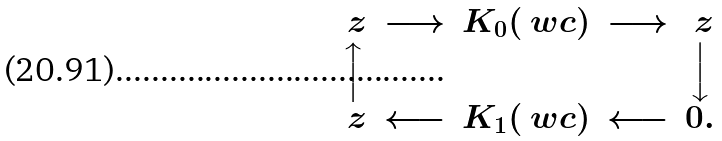Convert formula to latex. <formula><loc_0><loc_0><loc_500><loc_500>\begin{array} { c c c c c } \ z & \longrightarrow & K _ { 0 } ( \ w c ) & \longrightarrow & \ z \\ \Big \uparrow & & & & \Big \downarrow \\ \ z & \longleftarrow & K _ { 1 } ( \ w c ) & \longleftarrow & 0 . \end{array}</formula> 